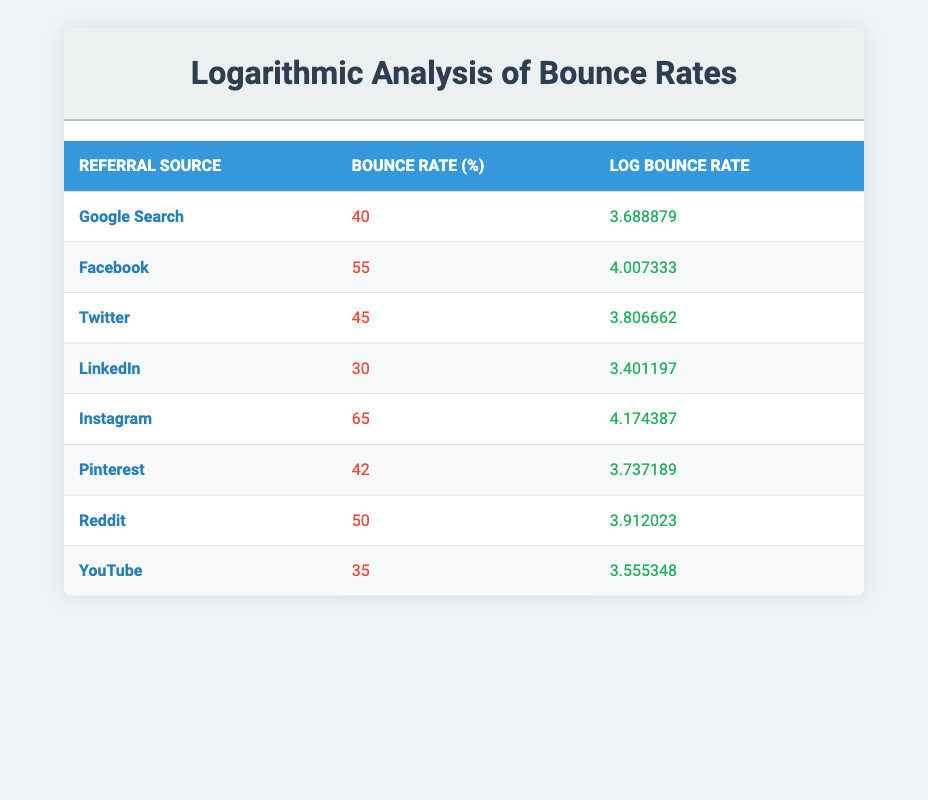What is the bounce rate for Instagram? The table shows the bounce rate for each referral source. Looking at the row for Instagram, the value in the Bounce Rate column is 65.
Answer: 65 What is the log bounce rate for LinkedIn? In the table, the log bounce rate for LinkedIn is found directly in its corresponding row, which shows a value of 3.401197.
Answer: 3.401197 Which referral source has the highest bounce rate? To determine which source has the highest bounce rate, we can compare all the values in the Bounce Rate column. The highest value is 65 for Instagram.
Answer: Instagram What is the average bounce rate of all sources mentioned? First, we sum all the bounce rates: 40 + 55 + 45 + 30 + 65 + 42 + 50 + 35 = 362. Then, we divide by the number of sources (8): 362 / 8 = 45.25.
Answer: 45.25 Is the log bounce rate for Facebook greater than 4? The log bounce rate for Facebook is 4.007333, which is indeed greater than 4. Therefore, the answer is yes.
Answer: Yes What is the difference in bounce rates between YouTube and Twitter? The bounce rate for YouTube is 35 and for Twitter is 45. The difference is calculated as 45 - 35 = 10.
Answer: 10 How many sources have a bounce rate greater than 50? By reviewing the table, we see that there are three sources with bounce rates higher than 50: Facebook (55), Instagram (65), and Reddit (50). So, there are 3 sources in total.
Answer: 2 Which referral source has the smallest log bounce rate? The smallest log bounce rate can be found by comparing all log bounce rate values. The log bounce rate for LinkedIn is 3.401197, which is the smallest among all listed.
Answer: LinkedIn 